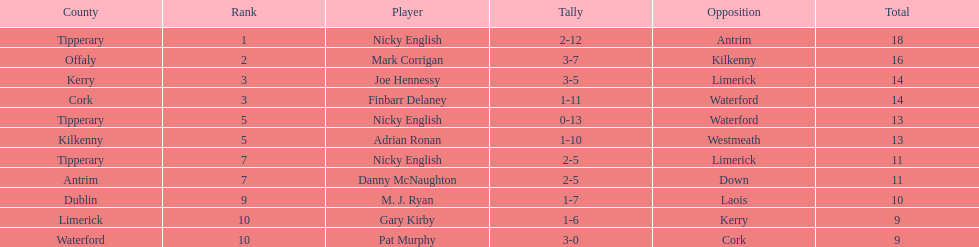What is the least total on the list? 9. 